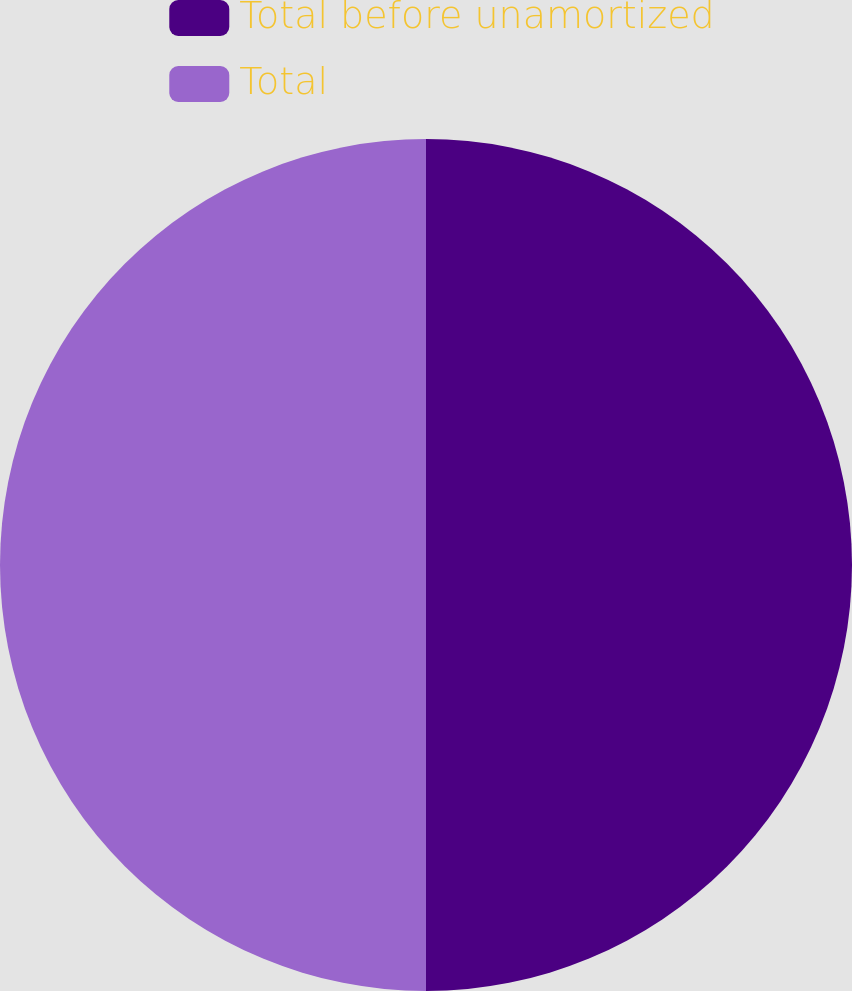Convert chart to OTSL. <chart><loc_0><loc_0><loc_500><loc_500><pie_chart><fcel>Total before unamortized<fcel>Total<nl><fcel>50.0%<fcel>50.0%<nl></chart> 